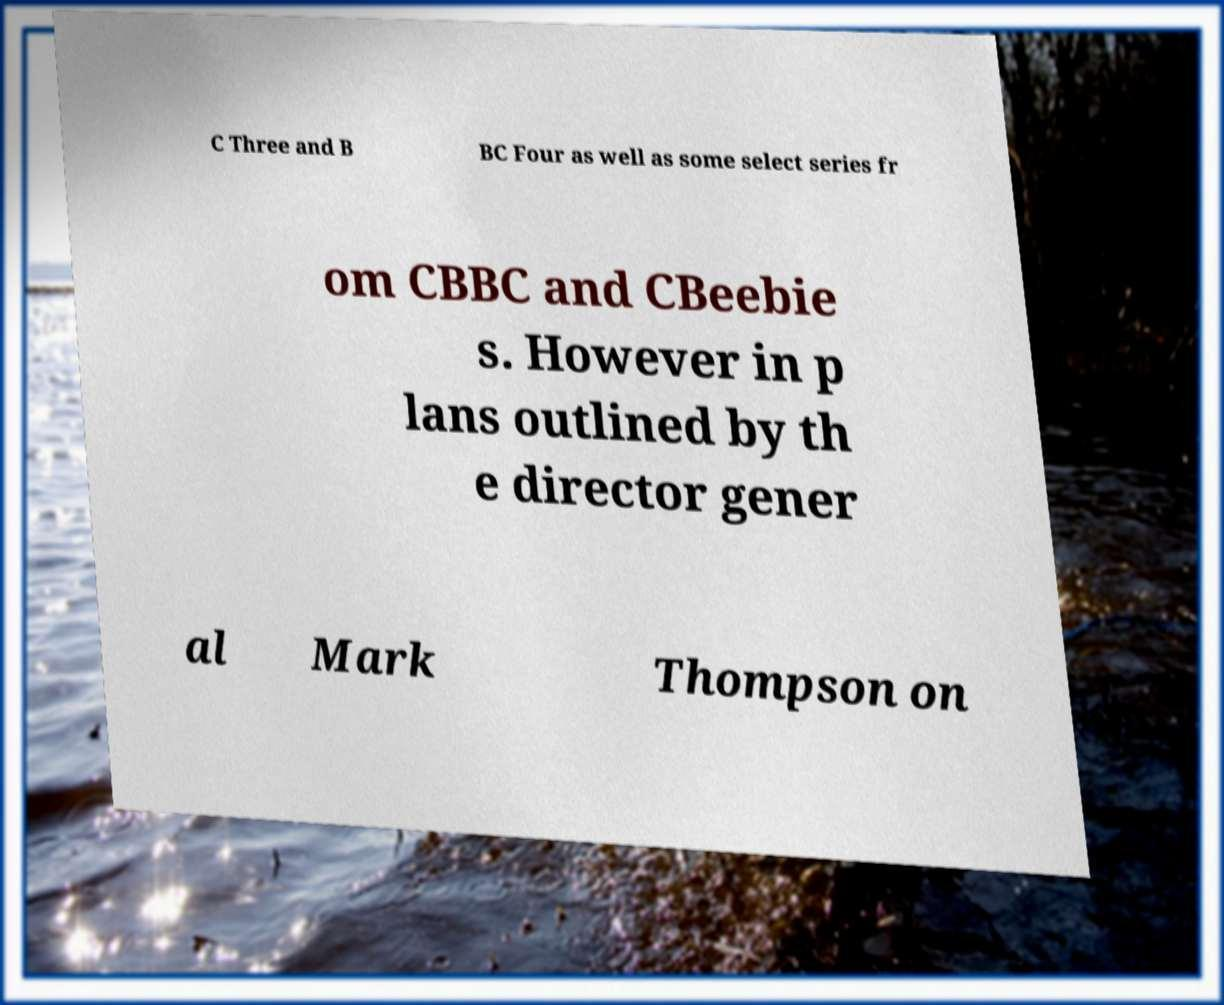Please read and relay the text visible in this image. What does it say? C Three and B BC Four as well as some select series fr om CBBC and CBeebie s. However in p lans outlined by th e director gener al Mark Thompson on 